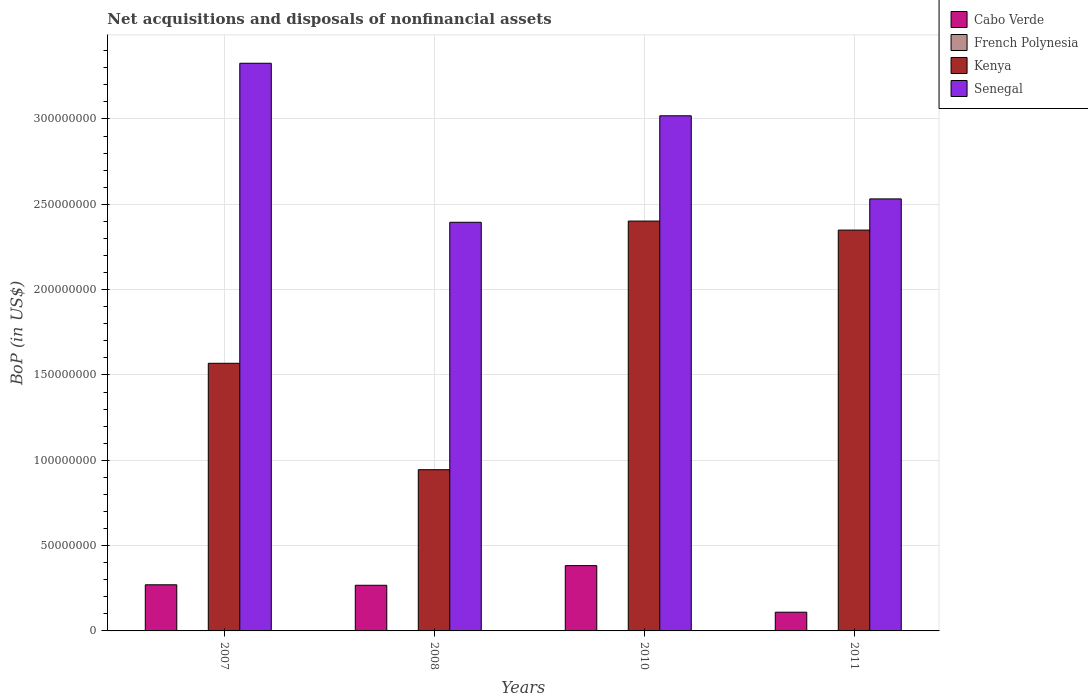How many different coloured bars are there?
Give a very brief answer. 4. How many groups of bars are there?
Ensure brevity in your answer.  4. How many bars are there on the 1st tick from the right?
Offer a terse response. 3. In how many cases, is the number of bars for a given year not equal to the number of legend labels?
Your answer should be compact. 3. What is the Balance of Payments in French Polynesia in 2008?
Keep it short and to the point. 8350.98. Across all years, what is the maximum Balance of Payments in French Polynesia?
Your response must be concise. 8350.98. Across all years, what is the minimum Balance of Payments in Cabo Verde?
Offer a very short reply. 1.10e+07. In which year was the Balance of Payments in French Polynesia maximum?
Offer a terse response. 2008. What is the total Balance of Payments in Kenya in the graph?
Ensure brevity in your answer.  7.26e+08. What is the difference between the Balance of Payments in Senegal in 2007 and that in 2011?
Provide a short and direct response. 7.95e+07. What is the difference between the Balance of Payments in Senegal in 2011 and the Balance of Payments in French Polynesia in 2008?
Provide a succinct answer. 2.53e+08. What is the average Balance of Payments in Cabo Verde per year?
Provide a succinct answer. 2.58e+07. In the year 2011, what is the difference between the Balance of Payments in Senegal and Balance of Payments in Cabo Verde?
Your answer should be compact. 2.42e+08. In how many years, is the Balance of Payments in Senegal greater than 270000000 US$?
Provide a short and direct response. 2. What is the ratio of the Balance of Payments in Senegal in 2007 to that in 2008?
Offer a very short reply. 1.39. Is the Balance of Payments in Kenya in 2007 less than that in 2010?
Give a very brief answer. Yes. What is the difference between the highest and the second highest Balance of Payments in Kenya?
Provide a short and direct response. 5.29e+06. What is the difference between the highest and the lowest Balance of Payments in Senegal?
Offer a terse response. 9.32e+07. Is the sum of the Balance of Payments in Cabo Verde in 2008 and 2010 greater than the maximum Balance of Payments in Kenya across all years?
Give a very brief answer. No. Is it the case that in every year, the sum of the Balance of Payments in Kenya and Balance of Payments in Senegal is greater than the sum of Balance of Payments in Cabo Verde and Balance of Payments in French Polynesia?
Offer a very short reply. Yes. How many years are there in the graph?
Offer a terse response. 4. What is the difference between two consecutive major ticks on the Y-axis?
Your answer should be very brief. 5.00e+07. Does the graph contain grids?
Keep it short and to the point. Yes. Where does the legend appear in the graph?
Offer a very short reply. Top right. How many legend labels are there?
Ensure brevity in your answer.  4. What is the title of the graph?
Make the answer very short. Net acquisitions and disposals of nonfinancial assets. Does "Mali" appear as one of the legend labels in the graph?
Provide a short and direct response. No. What is the label or title of the X-axis?
Give a very brief answer. Years. What is the label or title of the Y-axis?
Your answer should be compact. BoP (in US$). What is the BoP (in US$) in Cabo Verde in 2007?
Provide a short and direct response. 2.70e+07. What is the BoP (in US$) in Kenya in 2007?
Make the answer very short. 1.57e+08. What is the BoP (in US$) in Senegal in 2007?
Make the answer very short. 3.33e+08. What is the BoP (in US$) in Cabo Verde in 2008?
Make the answer very short. 2.67e+07. What is the BoP (in US$) of French Polynesia in 2008?
Your response must be concise. 8350.98. What is the BoP (in US$) in Kenya in 2008?
Your answer should be very brief. 9.45e+07. What is the BoP (in US$) in Senegal in 2008?
Offer a very short reply. 2.39e+08. What is the BoP (in US$) of Cabo Verde in 2010?
Keep it short and to the point. 3.83e+07. What is the BoP (in US$) in Kenya in 2010?
Make the answer very short. 2.40e+08. What is the BoP (in US$) of Senegal in 2010?
Provide a short and direct response. 3.02e+08. What is the BoP (in US$) in Cabo Verde in 2011?
Ensure brevity in your answer.  1.10e+07. What is the BoP (in US$) in Kenya in 2011?
Your answer should be compact. 2.35e+08. What is the BoP (in US$) in Senegal in 2011?
Give a very brief answer. 2.53e+08. Across all years, what is the maximum BoP (in US$) in Cabo Verde?
Make the answer very short. 3.83e+07. Across all years, what is the maximum BoP (in US$) in French Polynesia?
Offer a very short reply. 8350.98. Across all years, what is the maximum BoP (in US$) of Kenya?
Provide a short and direct response. 2.40e+08. Across all years, what is the maximum BoP (in US$) in Senegal?
Provide a succinct answer. 3.33e+08. Across all years, what is the minimum BoP (in US$) in Cabo Verde?
Your answer should be very brief. 1.10e+07. Across all years, what is the minimum BoP (in US$) of French Polynesia?
Provide a succinct answer. 0. Across all years, what is the minimum BoP (in US$) in Kenya?
Offer a terse response. 9.45e+07. Across all years, what is the minimum BoP (in US$) in Senegal?
Give a very brief answer. 2.39e+08. What is the total BoP (in US$) of Cabo Verde in the graph?
Keep it short and to the point. 1.03e+08. What is the total BoP (in US$) in French Polynesia in the graph?
Your answer should be very brief. 8350.98. What is the total BoP (in US$) in Kenya in the graph?
Ensure brevity in your answer.  7.26e+08. What is the total BoP (in US$) in Senegal in the graph?
Give a very brief answer. 1.13e+09. What is the difference between the BoP (in US$) in Cabo Verde in 2007 and that in 2008?
Give a very brief answer. 2.85e+05. What is the difference between the BoP (in US$) in Kenya in 2007 and that in 2008?
Your answer should be compact. 6.24e+07. What is the difference between the BoP (in US$) of Senegal in 2007 and that in 2008?
Your answer should be very brief. 9.32e+07. What is the difference between the BoP (in US$) of Cabo Verde in 2007 and that in 2010?
Provide a short and direct response. -1.12e+07. What is the difference between the BoP (in US$) in Kenya in 2007 and that in 2010?
Ensure brevity in your answer.  -8.33e+07. What is the difference between the BoP (in US$) in Senegal in 2007 and that in 2010?
Your answer should be compact. 3.08e+07. What is the difference between the BoP (in US$) in Cabo Verde in 2007 and that in 2011?
Ensure brevity in your answer.  1.61e+07. What is the difference between the BoP (in US$) in Kenya in 2007 and that in 2011?
Your answer should be compact. -7.81e+07. What is the difference between the BoP (in US$) of Senegal in 2007 and that in 2011?
Give a very brief answer. 7.95e+07. What is the difference between the BoP (in US$) in Cabo Verde in 2008 and that in 2010?
Your response must be concise. -1.15e+07. What is the difference between the BoP (in US$) in Kenya in 2008 and that in 2010?
Give a very brief answer. -1.46e+08. What is the difference between the BoP (in US$) of Senegal in 2008 and that in 2010?
Your answer should be compact. -6.24e+07. What is the difference between the BoP (in US$) of Cabo Verde in 2008 and that in 2011?
Give a very brief answer. 1.58e+07. What is the difference between the BoP (in US$) in Kenya in 2008 and that in 2011?
Give a very brief answer. -1.40e+08. What is the difference between the BoP (in US$) of Senegal in 2008 and that in 2011?
Provide a succinct answer. -1.37e+07. What is the difference between the BoP (in US$) in Cabo Verde in 2010 and that in 2011?
Provide a succinct answer. 2.73e+07. What is the difference between the BoP (in US$) in Kenya in 2010 and that in 2011?
Keep it short and to the point. 5.29e+06. What is the difference between the BoP (in US$) of Senegal in 2010 and that in 2011?
Keep it short and to the point. 4.87e+07. What is the difference between the BoP (in US$) in Cabo Verde in 2007 and the BoP (in US$) in French Polynesia in 2008?
Ensure brevity in your answer.  2.70e+07. What is the difference between the BoP (in US$) of Cabo Verde in 2007 and the BoP (in US$) of Kenya in 2008?
Give a very brief answer. -6.74e+07. What is the difference between the BoP (in US$) in Cabo Verde in 2007 and the BoP (in US$) in Senegal in 2008?
Offer a very short reply. -2.12e+08. What is the difference between the BoP (in US$) in Kenya in 2007 and the BoP (in US$) in Senegal in 2008?
Give a very brief answer. -8.26e+07. What is the difference between the BoP (in US$) in Cabo Verde in 2007 and the BoP (in US$) in Kenya in 2010?
Make the answer very short. -2.13e+08. What is the difference between the BoP (in US$) of Cabo Verde in 2007 and the BoP (in US$) of Senegal in 2010?
Your answer should be very brief. -2.75e+08. What is the difference between the BoP (in US$) of Kenya in 2007 and the BoP (in US$) of Senegal in 2010?
Give a very brief answer. -1.45e+08. What is the difference between the BoP (in US$) in Cabo Verde in 2007 and the BoP (in US$) in Kenya in 2011?
Provide a succinct answer. -2.08e+08. What is the difference between the BoP (in US$) of Cabo Verde in 2007 and the BoP (in US$) of Senegal in 2011?
Provide a short and direct response. -2.26e+08. What is the difference between the BoP (in US$) in Kenya in 2007 and the BoP (in US$) in Senegal in 2011?
Provide a short and direct response. -9.63e+07. What is the difference between the BoP (in US$) in Cabo Verde in 2008 and the BoP (in US$) in Kenya in 2010?
Offer a very short reply. -2.13e+08. What is the difference between the BoP (in US$) in Cabo Verde in 2008 and the BoP (in US$) in Senegal in 2010?
Give a very brief answer. -2.75e+08. What is the difference between the BoP (in US$) of French Polynesia in 2008 and the BoP (in US$) of Kenya in 2010?
Your answer should be compact. -2.40e+08. What is the difference between the BoP (in US$) of French Polynesia in 2008 and the BoP (in US$) of Senegal in 2010?
Offer a very short reply. -3.02e+08. What is the difference between the BoP (in US$) in Kenya in 2008 and the BoP (in US$) in Senegal in 2010?
Your answer should be compact. -2.07e+08. What is the difference between the BoP (in US$) of Cabo Verde in 2008 and the BoP (in US$) of Kenya in 2011?
Your answer should be very brief. -2.08e+08. What is the difference between the BoP (in US$) in Cabo Verde in 2008 and the BoP (in US$) in Senegal in 2011?
Offer a very short reply. -2.26e+08. What is the difference between the BoP (in US$) in French Polynesia in 2008 and the BoP (in US$) in Kenya in 2011?
Your answer should be very brief. -2.35e+08. What is the difference between the BoP (in US$) in French Polynesia in 2008 and the BoP (in US$) in Senegal in 2011?
Your response must be concise. -2.53e+08. What is the difference between the BoP (in US$) of Kenya in 2008 and the BoP (in US$) of Senegal in 2011?
Keep it short and to the point. -1.59e+08. What is the difference between the BoP (in US$) of Cabo Verde in 2010 and the BoP (in US$) of Kenya in 2011?
Provide a succinct answer. -1.97e+08. What is the difference between the BoP (in US$) in Cabo Verde in 2010 and the BoP (in US$) in Senegal in 2011?
Your answer should be very brief. -2.15e+08. What is the difference between the BoP (in US$) of Kenya in 2010 and the BoP (in US$) of Senegal in 2011?
Ensure brevity in your answer.  -1.30e+07. What is the average BoP (in US$) of Cabo Verde per year?
Give a very brief answer. 2.58e+07. What is the average BoP (in US$) of French Polynesia per year?
Provide a short and direct response. 2087.74. What is the average BoP (in US$) of Kenya per year?
Provide a succinct answer. 1.82e+08. What is the average BoP (in US$) in Senegal per year?
Your response must be concise. 2.82e+08. In the year 2007, what is the difference between the BoP (in US$) of Cabo Verde and BoP (in US$) of Kenya?
Provide a short and direct response. -1.30e+08. In the year 2007, what is the difference between the BoP (in US$) of Cabo Verde and BoP (in US$) of Senegal?
Keep it short and to the point. -3.06e+08. In the year 2007, what is the difference between the BoP (in US$) of Kenya and BoP (in US$) of Senegal?
Make the answer very short. -1.76e+08. In the year 2008, what is the difference between the BoP (in US$) in Cabo Verde and BoP (in US$) in French Polynesia?
Keep it short and to the point. 2.67e+07. In the year 2008, what is the difference between the BoP (in US$) in Cabo Verde and BoP (in US$) in Kenya?
Make the answer very short. -6.77e+07. In the year 2008, what is the difference between the BoP (in US$) in Cabo Verde and BoP (in US$) in Senegal?
Give a very brief answer. -2.13e+08. In the year 2008, what is the difference between the BoP (in US$) of French Polynesia and BoP (in US$) of Kenya?
Offer a terse response. -9.45e+07. In the year 2008, what is the difference between the BoP (in US$) of French Polynesia and BoP (in US$) of Senegal?
Keep it short and to the point. -2.39e+08. In the year 2008, what is the difference between the BoP (in US$) in Kenya and BoP (in US$) in Senegal?
Your response must be concise. -1.45e+08. In the year 2010, what is the difference between the BoP (in US$) of Cabo Verde and BoP (in US$) of Kenya?
Ensure brevity in your answer.  -2.02e+08. In the year 2010, what is the difference between the BoP (in US$) in Cabo Verde and BoP (in US$) in Senegal?
Your answer should be very brief. -2.64e+08. In the year 2010, what is the difference between the BoP (in US$) in Kenya and BoP (in US$) in Senegal?
Provide a short and direct response. -6.17e+07. In the year 2011, what is the difference between the BoP (in US$) of Cabo Verde and BoP (in US$) of Kenya?
Your answer should be compact. -2.24e+08. In the year 2011, what is the difference between the BoP (in US$) of Cabo Verde and BoP (in US$) of Senegal?
Offer a very short reply. -2.42e+08. In the year 2011, what is the difference between the BoP (in US$) of Kenya and BoP (in US$) of Senegal?
Your answer should be very brief. -1.83e+07. What is the ratio of the BoP (in US$) in Cabo Verde in 2007 to that in 2008?
Give a very brief answer. 1.01. What is the ratio of the BoP (in US$) in Kenya in 2007 to that in 2008?
Your answer should be very brief. 1.66. What is the ratio of the BoP (in US$) in Senegal in 2007 to that in 2008?
Make the answer very short. 1.39. What is the ratio of the BoP (in US$) in Cabo Verde in 2007 to that in 2010?
Your response must be concise. 0.71. What is the ratio of the BoP (in US$) of Kenya in 2007 to that in 2010?
Your answer should be compact. 0.65. What is the ratio of the BoP (in US$) in Senegal in 2007 to that in 2010?
Ensure brevity in your answer.  1.1. What is the ratio of the BoP (in US$) in Cabo Verde in 2007 to that in 2011?
Your answer should be very brief. 2.46. What is the ratio of the BoP (in US$) of Kenya in 2007 to that in 2011?
Provide a succinct answer. 0.67. What is the ratio of the BoP (in US$) in Senegal in 2007 to that in 2011?
Your answer should be very brief. 1.31. What is the ratio of the BoP (in US$) in Cabo Verde in 2008 to that in 2010?
Your response must be concise. 0.7. What is the ratio of the BoP (in US$) of Kenya in 2008 to that in 2010?
Keep it short and to the point. 0.39. What is the ratio of the BoP (in US$) of Senegal in 2008 to that in 2010?
Provide a succinct answer. 0.79. What is the ratio of the BoP (in US$) of Cabo Verde in 2008 to that in 2011?
Offer a very short reply. 2.44. What is the ratio of the BoP (in US$) of Kenya in 2008 to that in 2011?
Your answer should be compact. 0.4. What is the ratio of the BoP (in US$) in Senegal in 2008 to that in 2011?
Offer a very short reply. 0.95. What is the ratio of the BoP (in US$) in Cabo Verde in 2010 to that in 2011?
Keep it short and to the point. 3.49. What is the ratio of the BoP (in US$) in Kenya in 2010 to that in 2011?
Your answer should be very brief. 1.02. What is the ratio of the BoP (in US$) of Senegal in 2010 to that in 2011?
Your answer should be compact. 1.19. What is the difference between the highest and the second highest BoP (in US$) of Cabo Verde?
Your answer should be very brief. 1.12e+07. What is the difference between the highest and the second highest BoP (in US$) of Kenya?
Offer a very short reply. 5.29e+06. What is the difference between the highest and the second highest BoP (in US$) of Senegal?
Your answer should be very brief. 3.08e+07. What is the difference between the highest and the lowest BoP (in US$) in Cabo Verde?
Your response must be concise. 2.73e+07. What is the difference between the highest and the lowest BoP (in US$) of French Polynesia?
Keep it short and to the point. 8350.98. What is the difference between the highest and the lowest BoP (in US$) of Kenya?
Offer a terse response. 1.46e+08. What is the difference between the highest and the lowest BoP (in US$) of Senegal?
Your response must be concise. 9.32e+07. 